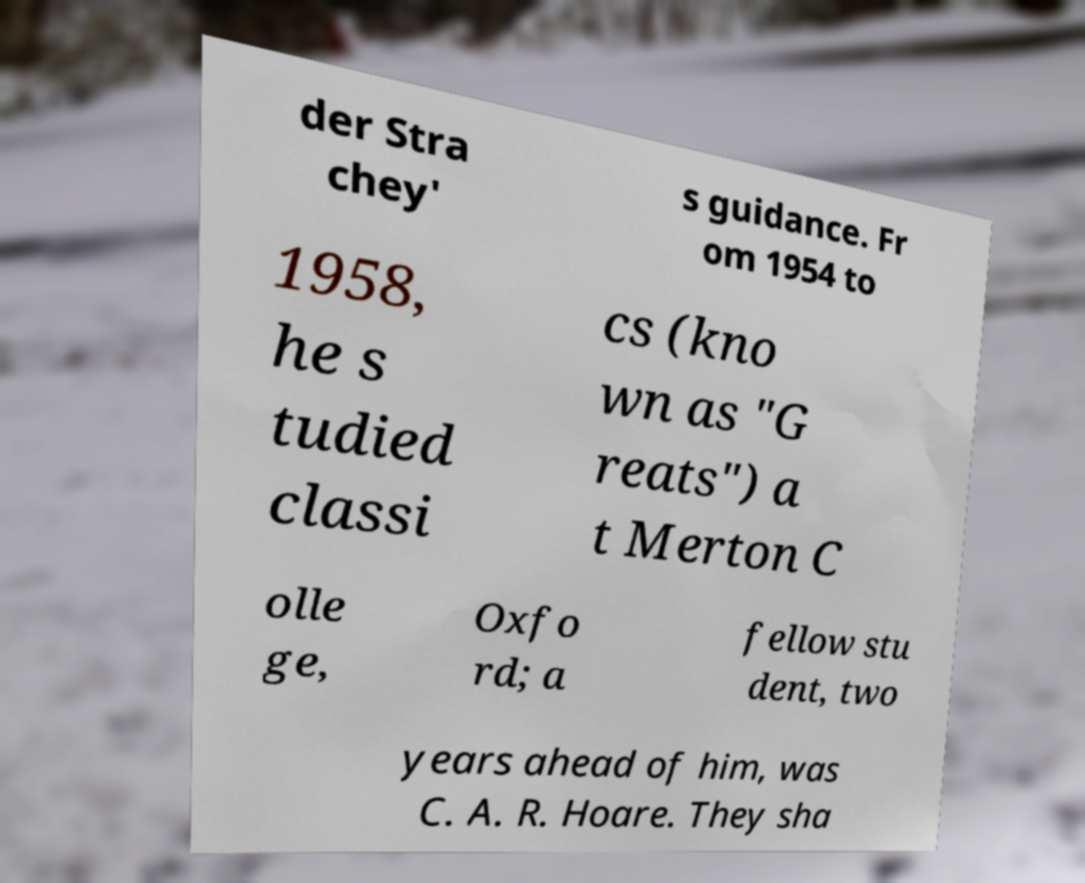Could you extract and type out the text from this image? der Stra chey' s guidance. Fr om 1954 to 1958, he s tudied classi cs (kno wn as "G reats") a t Merton C olle ge, Oxfo rd; a fellow stu dent, two years ahead of him, was C. A. R. Hoare. They sha 